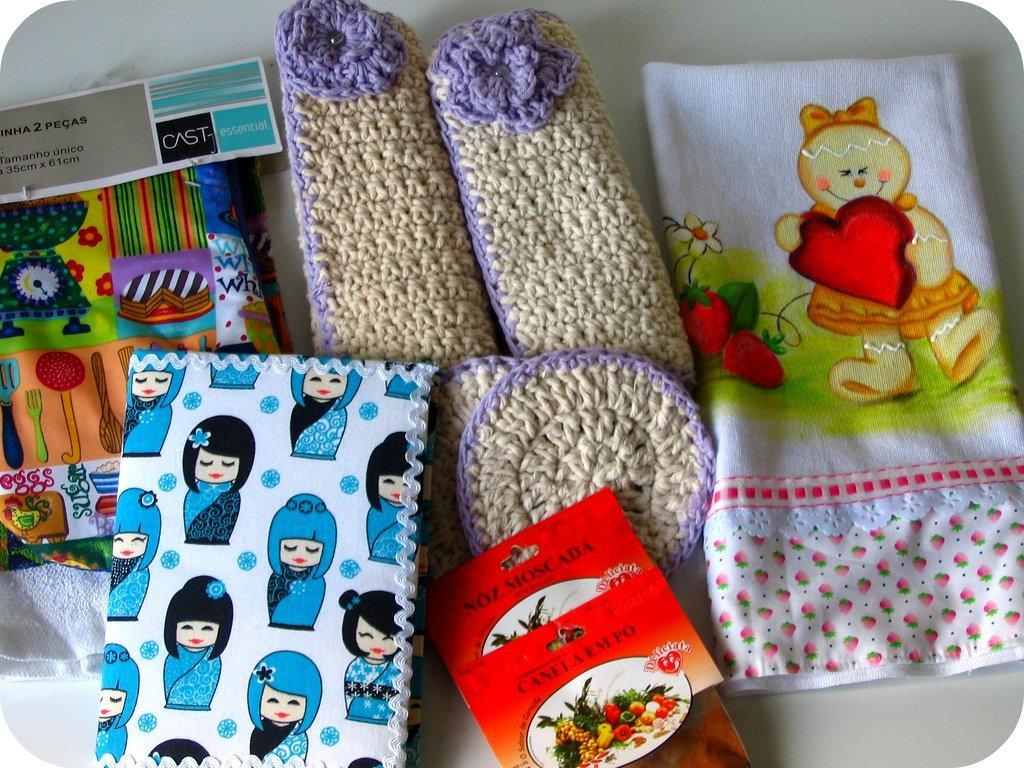What type of items can be seen in the image related to babies? There are baby accessories in the image. What material is used for one of the items in the image? There is a cloth in the image. What type of footwear is visible in the image? There are woolen shoes in the image. What is the shape of the packet in the image? The information provided does not specify the shape of the packet. What type of item is related to learning or reading in the image? There is a book in the image. What other type of cloth is present in the image? There is another piece of cloth in the image. How many cherries are on the book in the image? There are no cherries present in the image, and the book does not have any cherries on it. What type of fruit is being used as a hair accessory in the image? There is no fruit being used as a hair accessory in the image; the provided facts do not mention any hair or hair accessories. 